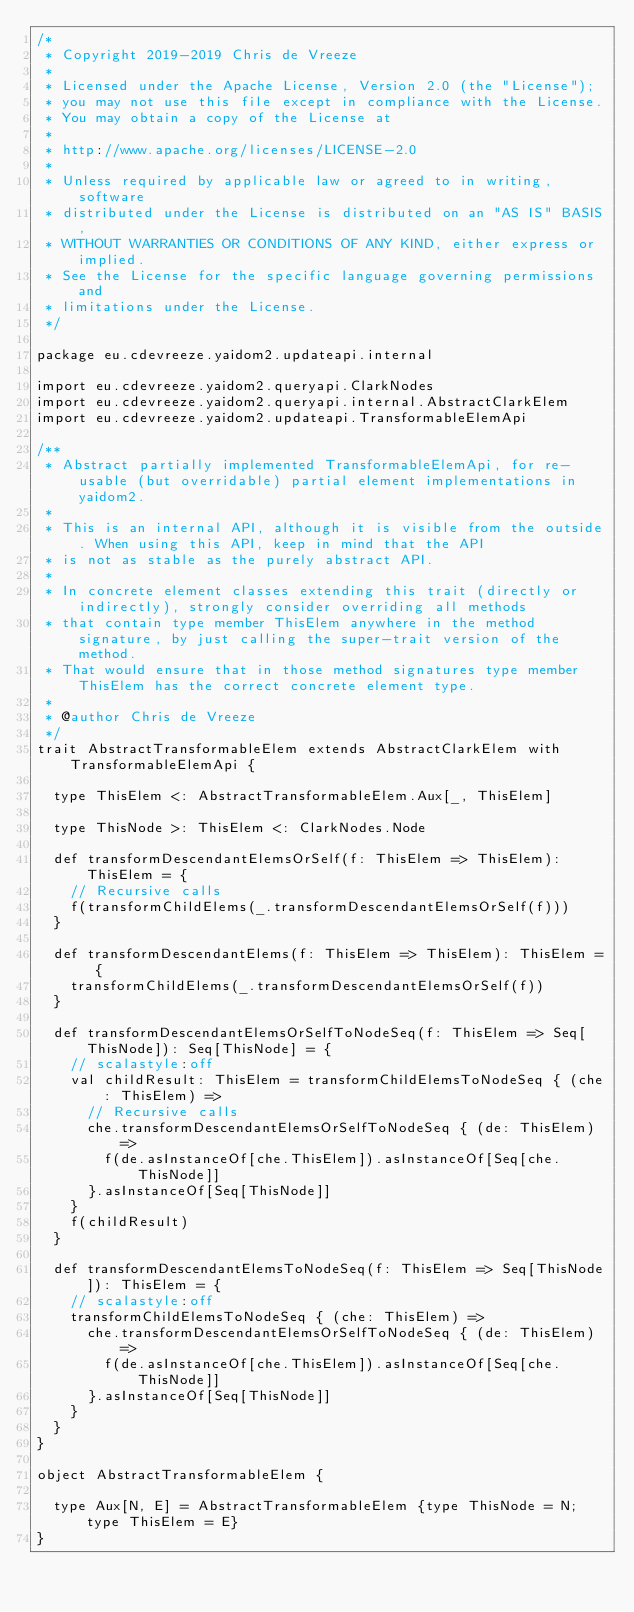Convert code to text. <code><loc_0><loc_0><loc_500><loc_500><_Scala_>/*
 * Copyright 2019-2019 Chris de Vreeze
 *
 * Licensed under the Apache License, Version 2.0 (the "License");
 * you may not use this file except in compliance with the License.
 * You may obtain a copy of the License at
 *
 * http://www.apache.org/licenses/LICENSE-2.0
 *
 * Unless required by applicable law or agreed to in writing, software
 * distributed under the License is distributed on an "AS IS" BASIS,
 * WITHOUT WARRANTIES OR CONDITIONS OF ANY KIND, either express or implied.
 * See the License for the specific language governing permissions and
 * limitations under the License.
 */

package eu.cdevreeze.yaidom2.updateapi.internal

import eu.cdevreeze.yaidom2.queryapi.ClarkNodes
import eu.cdevreeze.yaidom2.queryapi.internal.AbstractClarkElem
import eu.cdevreeze.yaidom2.updateapi.TransformableElemApi

/**
 * Abstract partially implemented TransformableElemApi, for re-usable (but overridable) partial element implementations in yaidom2.
 *
 * This is an internal API, although it is visible from the outside. When using this API, keep in mind that the API
 * is not as stable as the purely abstract API.
 *
 * In concrete element classes extending this trait (directly or indirectly), strongly consider overriding all methods
 * that contain type member ThisElem anywhere in the method signature, by just calling the super-trait version of the method.
 * That would ensure that in those method signatures type member ThisElem has the correct concrete element type.
 *
 * @author Chris de Vreeze
 */
trait AbstractTransformableElem extends AbstractClarkElem with TransformableElemApi {

  type ThisElem <: AbstractTransformableElem.Aux[_, ThisElem]

  type ThisNode >: ThisElem <: ClarkNodes.Node

  def transformDescendantElemsOrSelf(f: ThisElem => ThisElem): ThisElem = {
    // Recursive calls
    f(transformChildElems(_.transformDescendantElemsOrSelf(f)))
  }

  def transformDescendantElems(f: ThisElem => ThisElem): ThisElem = {
    transformChildElems(_.transformDescendantElemsOrSelf(f))
  }

  def transformDescendantElemsOrSelfToNodeSeq(f: ThisElem => Seq[ThisNode]): Seq[ThisNode] = {
    // scalastyle:off
    val childResult: ThisElem = transformChildElemsToNodeSeq { (che: ThisElem) =>
      // Recursive calls
      che.transformDescendantElemsOrSelfToNodeSeq { (de: ThisElem) =>
        f(de.asInstanceOf[che.ThisElem]).asInstanceOf[Seq[che.ThisNode]]
      }.asInstanceOf[Seq[ThisNode]]
    }
    f(childResult)
  }

  def transformDescendantElemsToNodeSeq(f: ThisElem => Seq[ThisNode]): ThisElem = {
    // scalastyle:off
    transformChildElemsToNodeSeq { (che: ThisElem) =>
      che.transformDescendantElemsOrSelfToNodeSeq { (de: ThisElem) =>
        f(de.asInstanceOf[che.ThisElem]).asInstanceOf[Seq[che.ThisNode]]
      }.asInstanceOf[Seq[ThisNode]]
    }
  }
}

object AbstractTransformableElem {

  type Aux[N, E] = AbstractTransformableElem {type ThisNode = N; type ThisElem = E}
}
</code> 